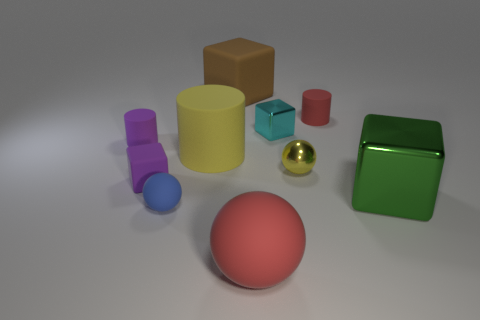Subtract all tiny matte cylinders. How many cylinders are left? 1 Subtract all brown cubes. How many cubes are left? 3 Subtract 1 cylinders. How many cylinders are left? 2 Subtract all cylinders. How many objects are left? 7 Subtract all gray cylinders. Subtract all red blocks. How many cylinders are left? 3 Subtract all small shiny cubes. Subtract all red spheres. How many objects are left? 8 Add 3 brown matte things. How many brown matte things are left? 4 Add 7 blue shiny balls. How many blue shiny balls exist? 7 Subtract 0 cyan balls. How many objects are left? 10 